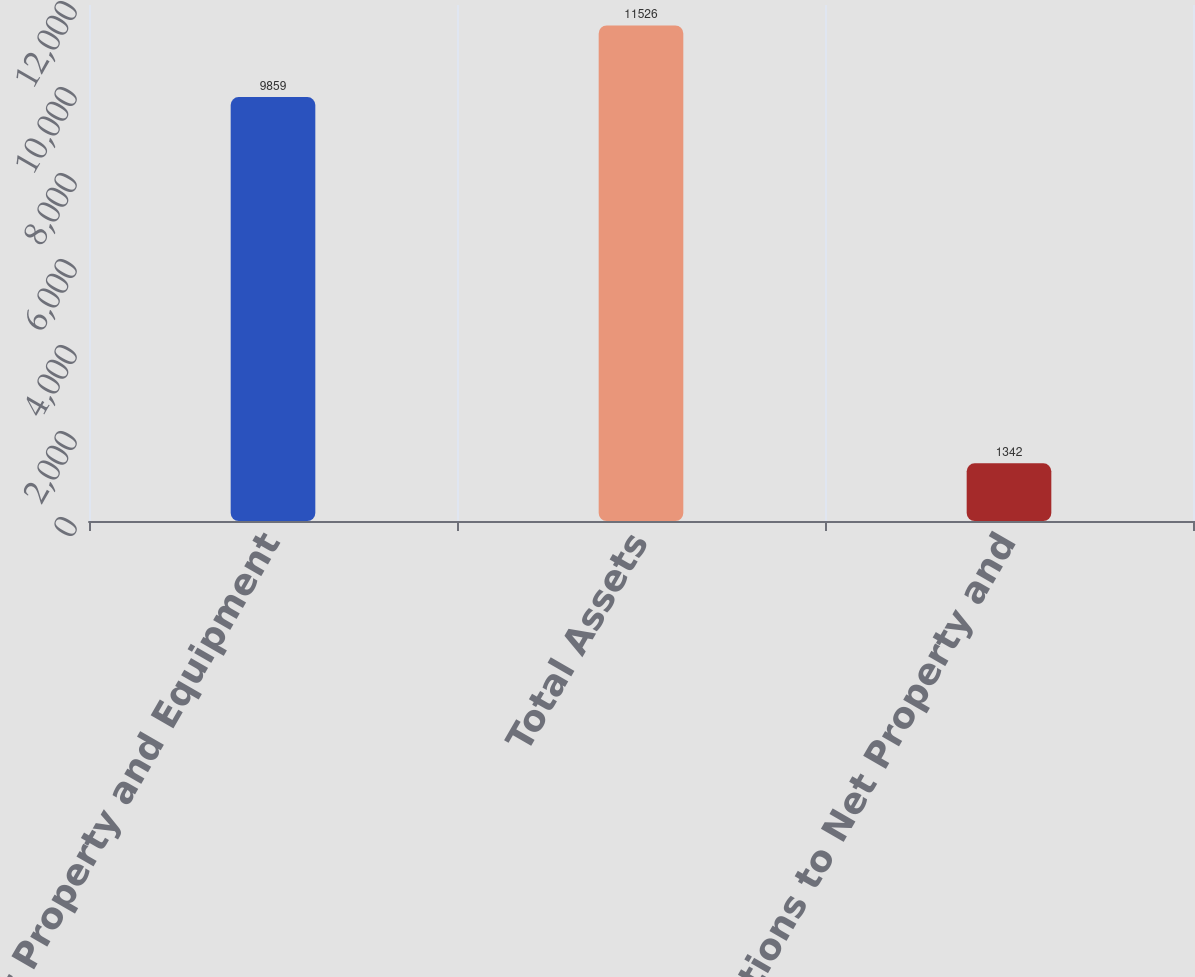Convert chart to OTSL. <chart><loc_0><loc_0><loc_500><loc_500><bar_chart><fcel>Net Property and Equipment<fcel>Total Assets<fcel>Additions to Net Property and<nl><fcel>9859<fcel>11526<fcel>1342<nl></chart> 